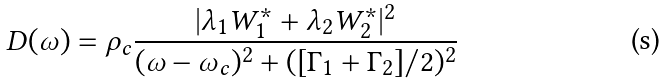<formula> <loc_0><loc_0><loc_500><loc_500>D ( \omega ) = \rho _ { c } \frac { | \lambda _ { 1 } W _ { 1 } ^ { \ast } + \lambda _ { 2 } W _ { 2 } ^ { \ast } | ^ { 2 } } { ( \omega - \omega _ { c } ) ^ { 2 } + ( [ \Gamma _ { 1 } + \Gamma _ { 2 } ] / 2 ) ^ { 2 } }</formula> 